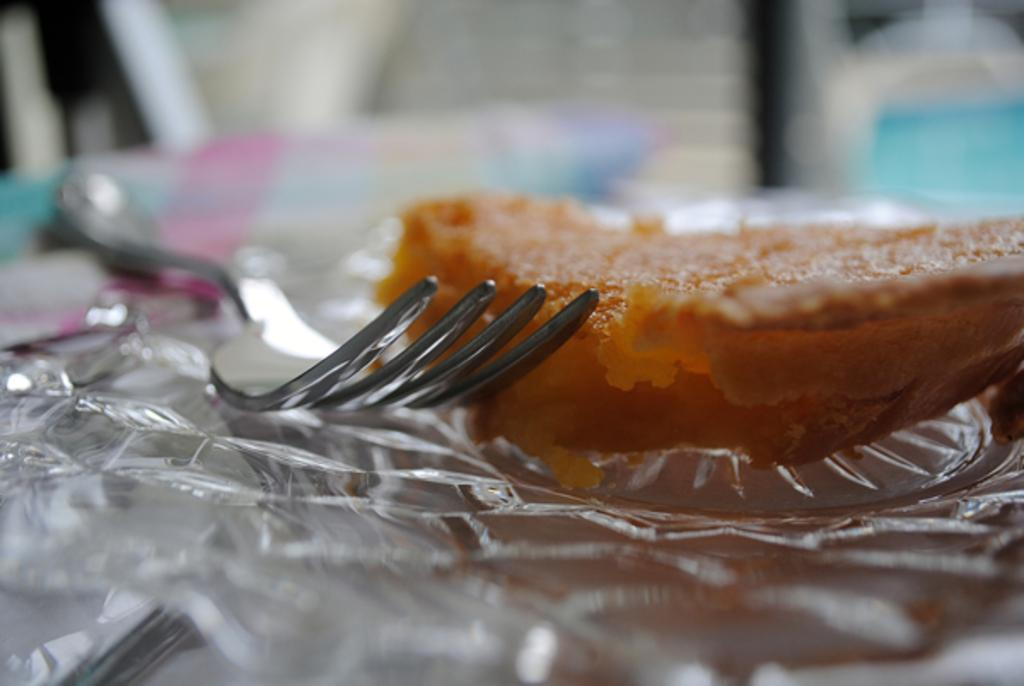What is on the plate in the image? There is a fork on the plate in the image. What else can be seen on the plate besides the fork? There is a food item present on the plate. What type of street is visible in the image? There is no street visible in the image; it only shows a plate with a fork and a food item. 